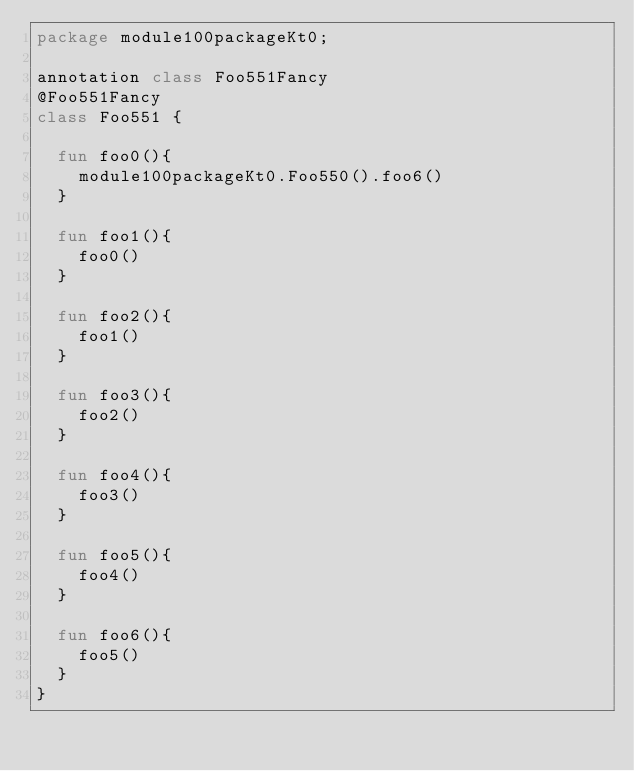Convert code to text. <code><loc_0><loc_0><loc_500><loc_500><_Kotlin_>package module100packageKt0;

annotation class Foo551Fancy
@Foo551Fancy
class Foo551 {

  fun foo0(){
    module100packageKt0.Foo550().foo6()
  }

  fun foo1(){
    foo0()
  }

  fun foo2(){
    foo1()
  }

  fun foo3(){
    foo2()
  }

  fun foo4(){
    foo3()
  }

  fun foo5(){
    foo4()
  }

  fun foo6(){
    foo5()
  }
}</code> 